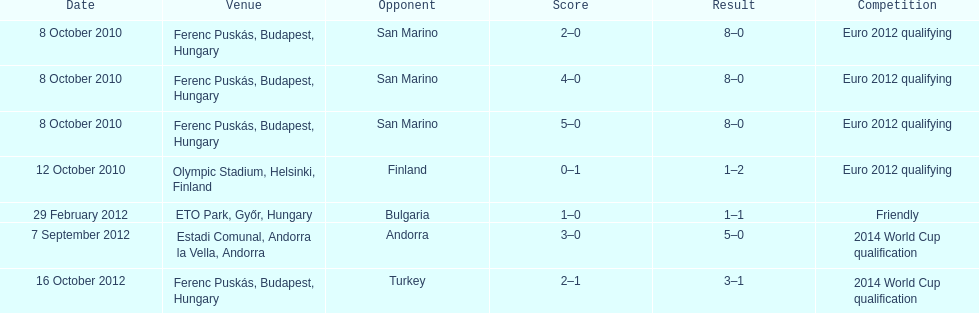In what year did ádám szalai make his next international goal after 2010? 2012. 